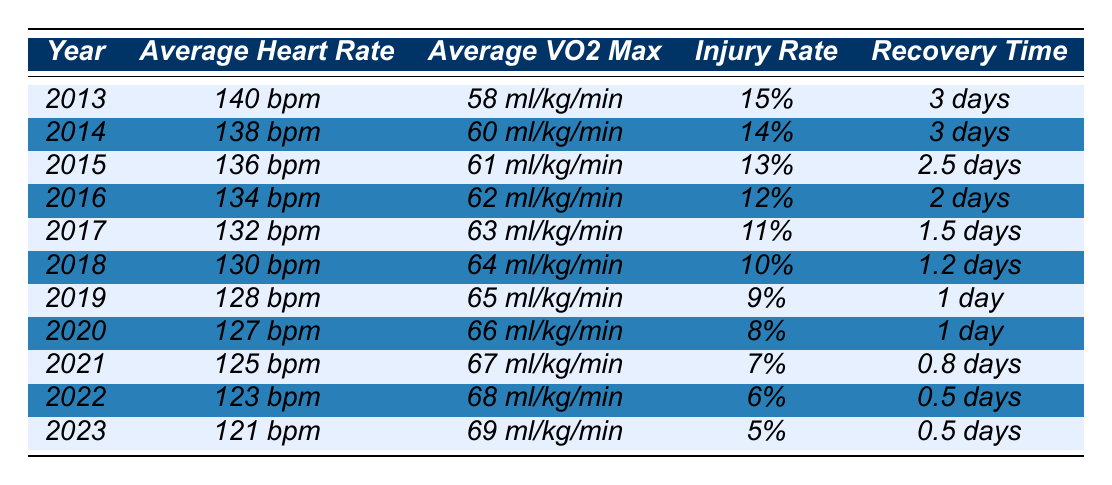What was the average heart rate of athletes in 2023? In the table, under the column for the average heart rate for the year 2023, the value listed is "121 bpm."
Answer: 121 bpm Which year had the highest average VO2 Max? The year with the highest average VO2 Max can be found by looking at the values in the relevant column; 2023 has an average VO2 Max of "69 ml/kg/min," which is the highest compared to all other years listed.
Answer: 2023 What was the injury rate in 2015? The injury rate for 2015 is listed in the table under the injury rate column. It shows "13%."
Answer: 13% Over the decade, how much did the average heart rate decrease from 2013 to 2023? The average heart rate in 2013 is "140 bpm," and in 2023 it is "121 bpm." The decrease can be calculated as 140 - 121 = 19 bpm.
Answer: 19 bpm What was the average recovery time in 2016? The recovery time for 2016 is specified in the recovery time column, which states "2 days."
Answer: 2 days In which year did the injury rate first fall below 10%? By examining the injury rates year by year, it can be seen that the injury rate dropped below 10% in the year 2018, where it is listed as "10%."
Answer: 2018 What is the trend in average VO2 Max from 2013 to 2023? By reviewing the VO2 Max values from 2013 (58 ml/kg/min) to 2023 (69 ml/kg/min), it is observed that these values consistently increase each year, indicating a positive trend in fitness metrics.
Answer: Increasing What was the recovery time in the year with the lowest injury rate? Checking the table, the lowest injury rate is in 2023, with a value of "5%". The recovery time for 2023 is "0.5 days."
Answer: 0.5 days Calculate the average recovery time for the years 2013 to 2016. The recovery times for those years are 3 days (2013), 3 days (2014), 2.5 days (2015), and 2 days (2016). The sum of these recovery times is (3 + 3 + 2.5 + 2) = 10.5 days. Dividing this by 4 gives an average recovery time of 10.5 / 4 = 2.625 days.
Answer: 2.625 days Did the average heart rate ever increase from one year to the next? Reviewing the average heart rates from year to year, none show an increase; each year the average heart rate decreases, confirming that the heart rate consistently reduced over the decade.
Answer: No 